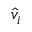Convert formula to latex. <formula><loc_0><loc_0><loc_500><loc_500>{ \hat { v } } _ { i }</formula> 